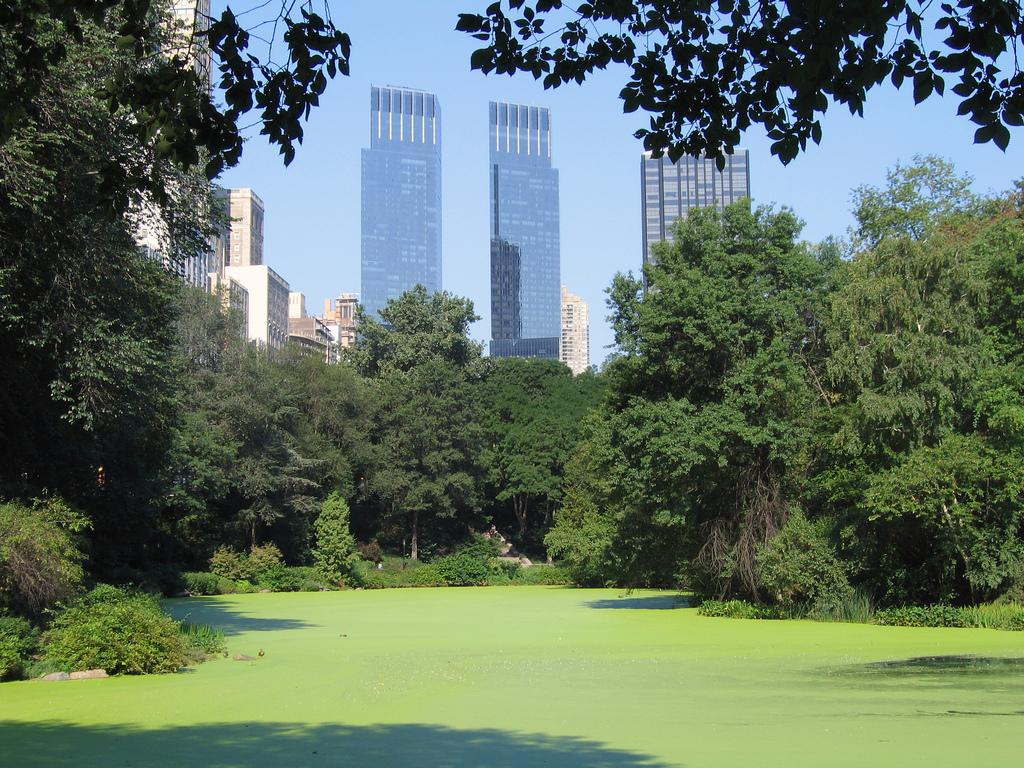What is the primary element in the image? There is water in the image. What is the color of the outermost layer of the water? The outermost layer of the water appears to be greenish in color. What can be seen in the background of the image? There are trees, buildings, windows, and the sky visible in the background of the image. What type of mint is growing near the water in the image? There is no mint visible in the image; it only features water with a greenish outer layer and background elements. What organization is responsible for maintaining the water in the image? There is no information about an organization responsible for maintaining the water in the image. 